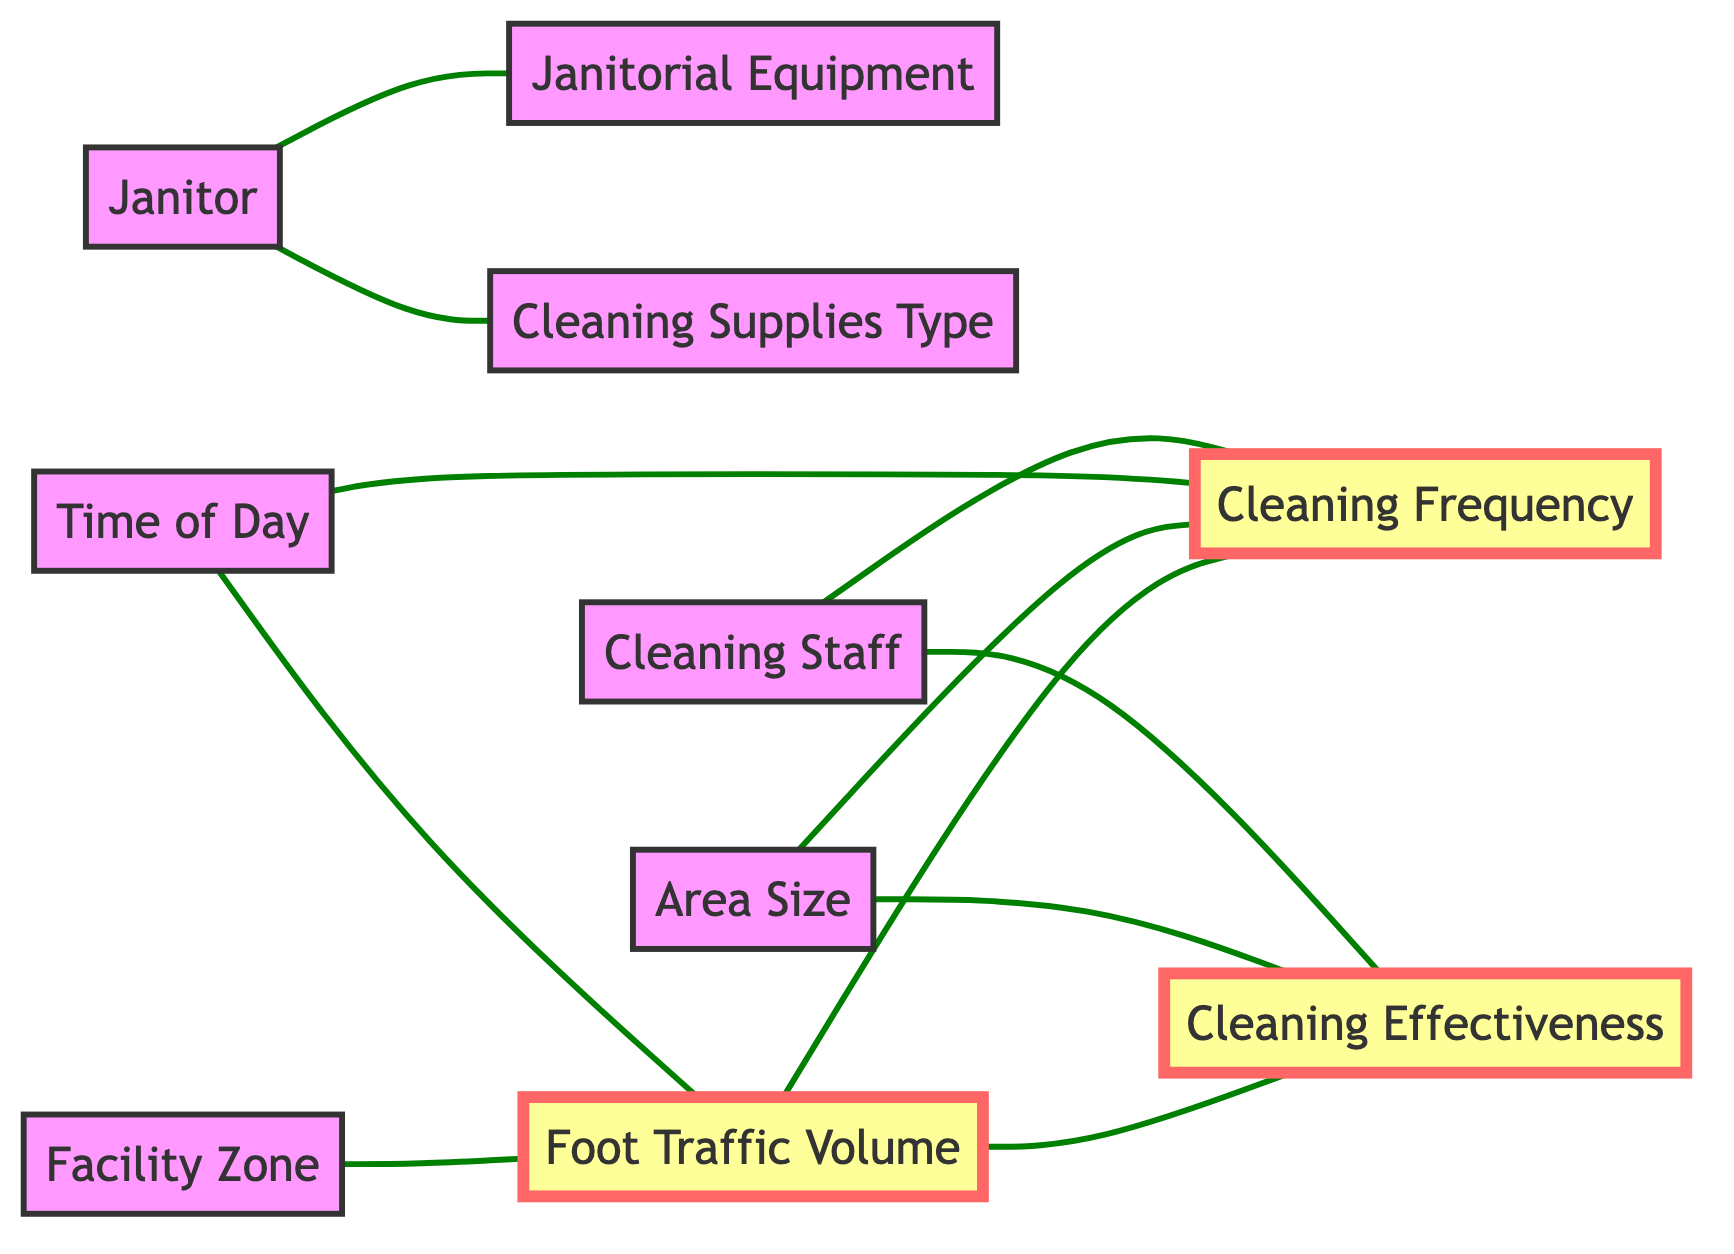What is the number of nodes in the diagram? The diagram lists a total of 10 unique entities, which are referred to as nodes. These nodes include Janitor, Janitorial Equipment, Cleaning Supplies Type, Foot Traffic Volume, Area Size, Cleaning Frequency, Cleaning Effectiveness, Facility Zone, Time of Day, and Cleaning Staff.
Answer: 10 Which node is directly connected to Cleaning Frequency? Cleaning Frequency is directly connected to several nodes, specifically Foot Traffic Volume, Area Size, Time of Day, and Cleaning Staff as shown by the edges linking them, indicating the influence of these elements on cleaning frequency.
Answer: Four What type of relationship does Facility Zone have with Foot Traffic Volume? Facility Zone is connected directly to Foot Traffic Volume in the diagram, indicating that changes or variations in the facility zone can affect foot traffic volume, showing a direct link between the two.
Answer: Direct How many edges are connected to the node labeled Foot Traffic Volume? The node labeled Foot Traffic Volume has three edges connecting it to other nodes: Cleaning Frequency, Cleaning Effectiveness, and Facility Zone. This shows its significant role in the overall cleanliness analysis.
Answer: Three Which nodes influence Cleaning Effectiveness? Cleaning Effectiveness is influenced by both Foot Traffic Volume and Area Size according to the edges in the diagram, indicating that these factors play a critical role in determining how effective the cleaning processes are.
Answer: Foot Traffic Volume, Area Size What is the relationship between Time of Day and Cleaning Frequency? Time of Day is directly connected to Cleaning Frequency through an edge, indicating that the timing of cleaning activities is likely to impact the frequency at which areas are cleaned.
Answer: Direct How many main factors interact with Foot Traffic Volume? Foot Traffic Volume interacts with four main factors in the diagram, which are Cleaning Frequency, Cleaning Effectiveness, Facility Zone, and Time of Day, demonstrating its multifaceted role in cleanliness assessment.
Answer: Four Which node connects with both Janitor and Cleaning Supplies Type? The node Janitor connects directly to both Janitorial Equipment and Cleaning Supplies Type, indicating the janitor's role in selecting and utilizing the required equipment and supplies for cleanliness maintenance.
Answer: Janitorial Equipment, Cleaning Supplies Type Which type of graph is used to represent the relationships in this analysis? The diagram is represented as an Undirected Graph, where the edges do not have a direction, indicating that the relationships are two-way between connected nodes.
Answer: Undirected Graph 